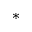<formula> <loc_0><loc_0><loc_500><loc_500>^ { * }</formula> 